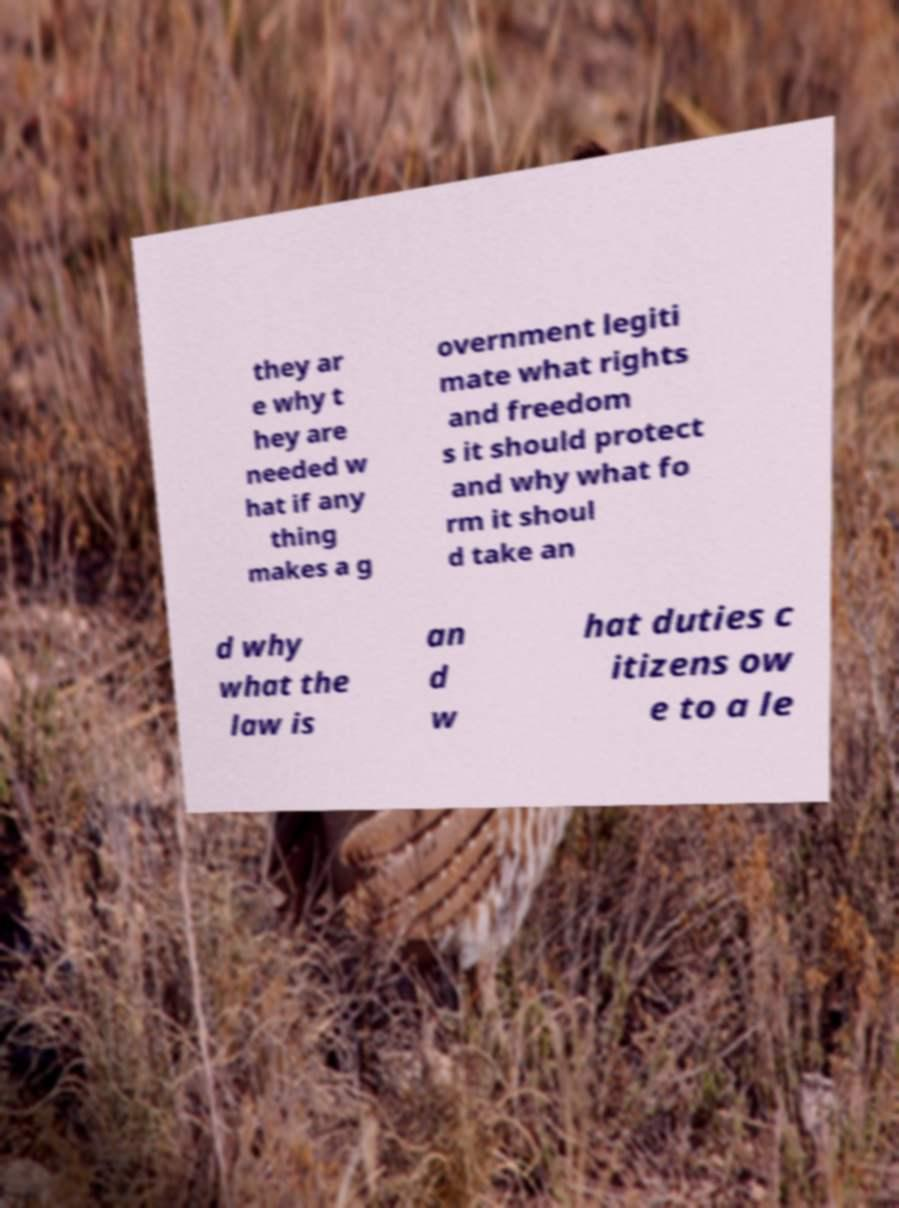Please identify and transcribe the text found in this image. they ar e why t hey are needed w hat if any thing makes a g overnment legiti mate what rights and freedom s it should protect and why what fo rm it shoul d take an d why what the law is an d w hat duties c itizens ow e to a le 